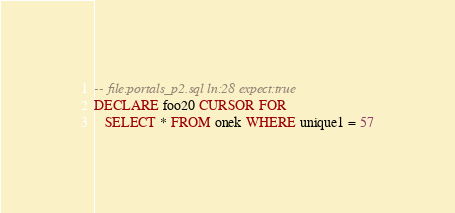Convert code to text. <code><loc_0><loc_0><loc_500><loc_500><_SQL_>-- file:portals_p2.sql ln:28 expect:true
DECLARE foo20 CURSOR FOR
   SELECT * FROM onek WHERE unique1 = 57
</code> 